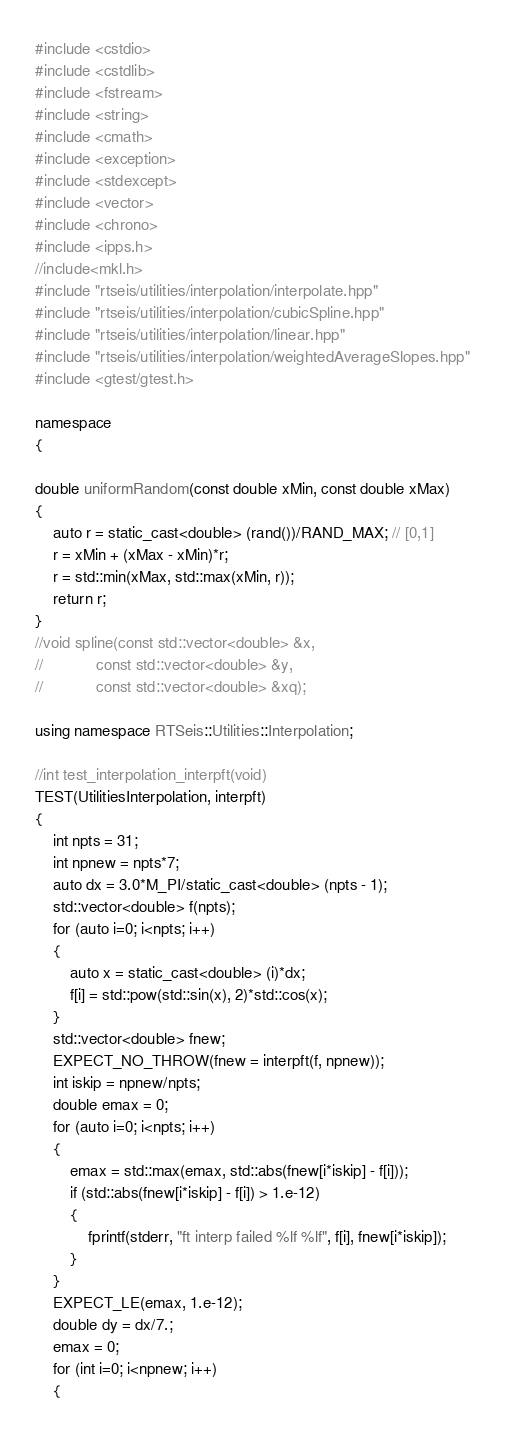Convert code to text. <code><loc_0><loc_0><loc_500><loc_500><_C++_>#include <cstdio>
#include <cstdlib>
#include <fstream>
#include <string>
#include <cmath>
#include <exception>
#include <stdexcept>
#include <vector>
#include <chrono>
#include <ipps.h>
//include<mkl.h>
#include "rtseis/utilities/interpolation/interpolate.hpp"
#include "rtseis/utilities/interpolation/cubicSpline.hpp"
#include "rtseis/utilities/interpolation/linear.hpp"
#include "rtseis/utilities/interpolation/weightedAverageSlopes.hpp"
#include <gtest/gtest.h>

namespace
{

double uniformRandom(const double xMin, const double xMax)
{
    auto r = static_cast<double> (rand())/RAND_MAX; // [0,1]
    r = xMin + (xMax - xMin)*r;
    r = std::min(xMax, std::max(xMin, r));
    return r;
}
//void spline(const std::vector<double> &x,
//            const std::vector<double> &y,
//            const std::vector<double> &xq);

using namespace RTSeis::Utilities::Interpolation;

//int test_interpolation_interpft(void)
TEST(UtilitiesInterpolation, interpft)
{
    int npts = 31;
    int npnew = npts*7;
    auto dx = 3.0*M_PI/static_cast<double> (npts - 1);
    std::vector<double> f(npts);
    for (auto i=0; i<npts; i++)
    {
        auto x = static_cast<double> (i)*dx;
        f[i] = std::pow(std::sin(x), 2)*std::cos(x);
    }
    std::vector<double> fnew;
    EXPECT_NO_THROW(fnew = interpft(f, npnew));
    int iskip = npnew/npts;
    double emax = 0;
    for (auto i=0; i<npts; i++)
    {
        emax = std::max(emax, std::abs(fnew[i*iskip] - f[i]));
        if (std::abs(fnew[i*iskip] - f[i]) > 1.e-12)
        {
            fprintf(stderr, "ft interp failed %lf %lf", f[i], fnew[i*iskip]);
        }
    }
    EXPECT_LE(emax, 1.e-12);
    double dy = dx/7.;
    emax = 0;
    for (int i=0; i<npnew; i++)
    {</code> 